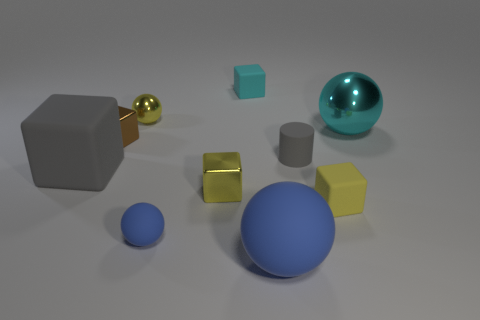Subtract all cylinders. How many objects are left? 9 Subtract 1 cylinders. How many cylinders are left? 0 Subtract all purple spheres. Subtract all purple cylinders. How many spheres are left? 4 Subtract all yellow cubes. How many yellow balls are left? 1 Subtract all tiny metallic things. Subtract all big gray objects. How many objects are left? 6 Add 6 yellow shiny cubes. How many yellow shiny cubes are left? 7 Add 6 big gray rubber objects. How many big gray rubber objects exist? 7 Subtract all gray blocks. How many blocks are left? 4 Subtract all big blocks. How many blocks are left? 4 Subtract 0 gray spheres. How many objects are left? 10 